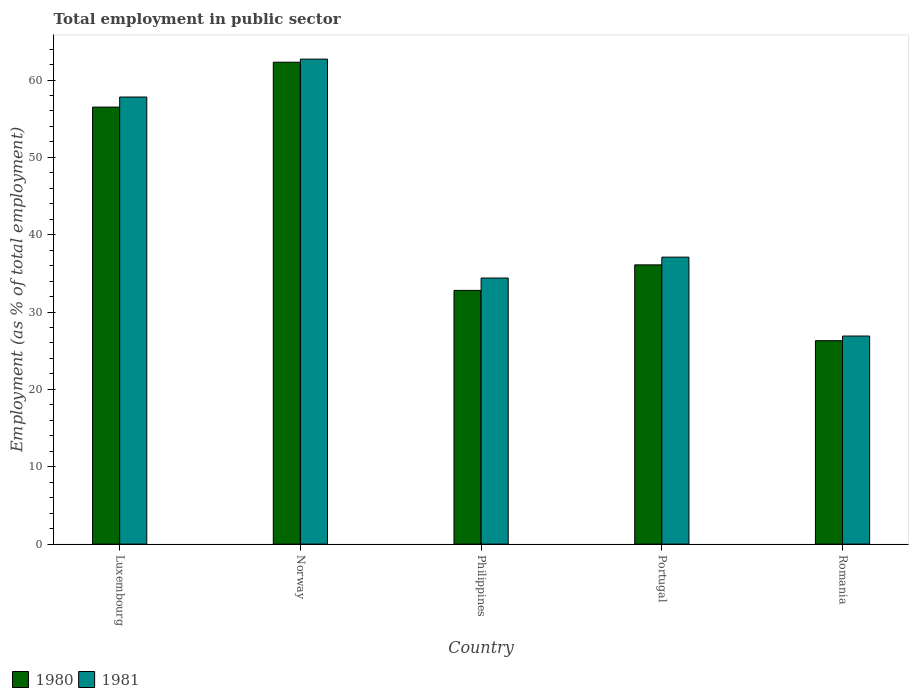What is the label of the 4th group of bars from the left?
Provide a succinct answer. Portugal. What is the employment in public sector in 1981 in Romania?
Your answer should be compact. 26.9. Across all countries, what is the maximum employment in public sector in 1980?
Your response must be concise. 62.3. Across all countries, what is the minimum employment in public sector in 1980?
Ensure brevity in your answer.  26.3. In which country was the employment in public sector in 1980 maximum?
Ensure brevity in your answer.  Norway. In which country was the employment in public sector in 1980 minimum?
Give a very brief answer. Romania. What is the total employment in public sector in 1981 in the graph?
Offer a very short reply. 218.9. What is the difference between the employment in public sector in 1981 in Philippines and that in Portugal?
Offer a very short reply. -2.7. What is the average employment in public sector in 1981 per country?
Your response must be concise. 43.78. What is the difference between the employment in public sector of/in 1980 and employment in public sector of/in 1981 in Portugal?
Your response must be concise. -1. What is the ratio of the employment in public sector in 1980 in Luxembourg to that in Norway?
Provide a succinct answer. 0.91. Is the difference between the employment in public sector in 1980 in Philippines and Portugal greater than the difference between the employment in public sector in 1981 in Philippines and Portugal?
Give a very brief answer. No. What is the difference between the highest and the second highest employment in public sector in 1980?
Make the answer very short. 20.4. Is the sum of the employment in public sector in 1980 in Philippines and Portugal greater than the maximum employment in public sector in 1981 across all countries?
Make the answer very short. Yes. How many bars are there?
Give a very brief answer. 10. Are all the bars in the graph horizontal?
Your response must be concise. No. Does the graph contain grids?
Offer a very short reply. No. Where does the legend appear in the graph?
Your answer should be compact. Bottom left. What is the title of the graph?
Provide a short and direct response. Total employment in public sector. Does "1960" appear as one of the legend labels in the graph?
Your response must be concise. No. What is the label or title of the X-axis?
Keep it short and to the point. Country. What is the label or title of the Y-axis?
Give a very brief answer. Employment (as % of total employment). What is the Employment (as % of total employment) of 1980 in Luxembourg?
Make the answer very short. 56.5. What is the Employment (as % of total employment) of 1981 in Luxembourg?
Provide a succinct answer. 57.8. What is the Employment (as % of total employment) of 1980 in Norway?
Keep it short and to the point. 62.3. What is the Employment (as % of total employment) in 1981 in Norway?
Ensure brevity in your answer.  62.7. What is the Employment (as % of total employment) in 1980 in Philippines?
Your answer should be very brief. 32.8. What is the Employment (as % of total employment) of 1981 in Philippines?
Give a very brief answer. 34.4. What is the Employment (as % of total employment) in 1980 in Portugal?
Your answer should be very brief. 36.1. What is the Employment (as % of total employment) of 1981 in Portugal?
Make the answer very short. 37.1. What is the Employment (as % of total employment) in 1980 in Romania?
Your answer should be compact. 26.3. What is the Employment (as % of total employment) of 1981 in Romania?
Provide a succinct answer. 26.9. Across all countries, what is the maximum Employment (as % of total employment) of 1980?
Ensure brevity in your answer.  62.3. Across all countries, what is the maximum Employment (as % of total employment) of 1981?
Provide a short and direct response. 62.7. Across all countries, what is the minimum Employment (as % of total employment) of 1980?
Keep it short and to the point. 26.3. Across all countries, what is the minimum Employment (as % of total employment) in 1981?
Ensure brevity in your answer.  26.9. What is the total Employment (as % of total employment) in 1980 in the graph?
Your answer should be compact. 214. What is the total Employment (as % of total employment) in 1981 in the graph?
Your answer should be compact. 218.9. What is the difference between the Employment (as % of total employment) in 1980 in Luxembourg and that in Philippines?
Provide a short and direct response. 23.7. What is the difference between the Employment (as % of total employment) of 1981 in Luxembourg and that in Philippines?
Offer a very short reply. 23.4. What is the difference between the Employment (as % of total employment) of 1980 in Luxembourg and that in Portugal?
Your answer should be compact. 20.4. What is the difference between the Employment (as % of total employment) in 1981 in Luxembourg and that in Portugal?
Your answer should be very brief. 20.7. What is the difference between the Employment (as % of total employment) in 1980 in Luxembourg and that in Romania?
Your response must be concise. 30.2. What is the difference between the Employment (as % of total employment) of 1981 in Luxembourg and that in Romania?
Your answer should be very brief. 30.9. What is the difference between the Employment (as % of total employment) in 1980 in Norway and that in Philippines?
Offer a very short reply. 29.5. What is the difference between the Employment (as % of total employment) of 1981 in Norway and that in Philippines?
Your answer should be very brief. 28.3. What is the difference between the Employment (as % of total employment) in 1980 in Norway and that in Portugal?
Your response must be concise. 26.2. What is the difference between the Employment (as % of total employment) in 1981 in Norway and that in Portugal?
Provide a short and direct response. 25.6. What is the difference between the Employment (as % of total employment) of 1980 in Norway and that in Romania?
Give a very brief answer. 36. What is the difference between the Employment (as % of total employment) in 1981 in Norway and that in Romania?
Offer a very short reply. 35.8. What is the difference between the Employment (as % of total employment) in 1981 in Philippines and that in Portugal?
Offer a terse response. -2.7. What is the difference between the Employment (as % of total employment) in 1981 in Portugal and that in Romania?
Provide a short and direct response. 10.2. What is the difference between the Employment (as % of total employment) of 1980 in Luxembourg and the Employment (as % of total employment) of 1981 in Norway?
Provide a short and direct response. -6.2. What is the difference between the Employment (as % of total employment) of 1980 in Luxembourg and the Employment (as % of total employment) of 1981 in Philippines?
Ensure brevity in your answer.  22.1. What is the difference between the Employment (as % of total employment) of 1980 in Luxembourg and the Employment (as % of total employment) of 1981 in Portugal?
Your answer should be very brief. 19.4. What is the difference between the Employment (as % of total employment) of 1980 in Luxembourg and the Employment (as % of total employment) of 1981 in Romania?
Offer a very short reply. 29.6. What is the difference between the Employment (as % of total employment) in 1980 in Norway and the Employment (as % of total employment) in 1981 in Philippines?
Your answer should be very brief. 27.9. What is the difference between the Employment (as % of total employment) of 1980 in Norway and the Employment (as % of total employment) of 1981 in Portugal?
Keep it short and to the point. 25.2. What is the difference between the Employment (as % of total employment) in 1980 in Norway and the Employment (as % of total employment) in 1981 in Romania?
Give a very brief answer. 35.4. What is the difference between the Employment (as % of total employment) in 1980 in Philippines and the Employment (as % of total employment) in 1981 in Romania?
Offer a very short reply. 5.9. What is the difference between the Employment (as % of total employment) in 1980 in Portugal and the Employment (as % of total employment) in 1981 in Romania?
Offer a very short reply. 9.2. What is the average Employment (as % of total employment) in 1980 per country?
Ensure brevity in your answer.  42.8. What is the average Employment (as % of total employment) in 1981 per country?
Your answer should be very brief. 43.78. What is the difference between the Employment (as % of total employment) in 1980 and Employment (as % of total employment) in 1981 in Philippines?
Your answer should be compact. -1.6. What is the difference between the Employment (as % of total employment) of 1980 and Employment (as % of total employment) of 1981 in Portugal?
Provide a succinct answer. -1. What is the difference between the Employment (as % of total employment) of 1980 and Employment (as % of total employment) of 1981 in Romania?
Your response must be concise. -0.6. What is the ratio of the Employment (as % of total employment) in 1980 in Luxembourg to that in Norway?
Offer a terse response. 0.91. What is the ratio of the Employment (as % of total employment) in 1981 in Luxembourg to that in Norway?
Your answer should be very brief. 0.92. What is the ratio of the Employment (as % of total employment) of 1980 in Luxembourg to that in Philippines?
Your response must be concise. 1.72. What is the ratio of the Employment (as % of total employment) in 1981 in Luxembourg to that in Philippines?
Offer a terse response. 1.68. What is the ratio of the Employment (as % of total employment) in 1980 in Luxembourg to that in Portugal?
Your response must be concise. 1.57. What is the ratio of the Employment (as % of total employment) of 1981 in Luxembourg to that in Portugal?
Offer a very short reply. 1.56. What is the ratio of the Employment (as % of total employment) in 1980 in Luxembourg to that in Romania?
Ensure brevity in your answer.  2.15. What is the ratio of the Employment (as % of total employment) of 1981 in Luxembourg to that in Romania?
Provide a short and direct response. 2.15. What is the ratio of the Employment (as % of total employment) of 1980 in Norway to that in Philippines?
Offer a very short reply. 1.9. What is the ratio of the Employment (as % of total employment) in 1981 in Norway to that in Philippines?
Offer a terse response. 1.82. What is the ratio of the Employment (as % of total employment) of 1980 in Norway to that in Portugal?
Offer a very short reply. 1.73. What is the ratio of the Employment (as % of total employment) of 1981 in Norway to that in Portugal?
Provide a succinct answer. 1.69. What is the ratio of the Employment (as % of total employment) of 1980 in Norway to that in Romania?
Provide a short and direct response. 2.37. What is the ratio of the Employment (as % of total employment) of 1981 in Norway to that in Romania?
Ensure brevity in your answer.  2.33. What is the ratio of the Employment (as % of total employment) of 1980 in Philippines to that in Portugal?
Provide a succinct answer. 0.91. What is the ratio of the Employment (as % of total employment) in 1981 in Philippines to that in Portugal?
Give a very brief answer. 0.93. What is the ratio of the Employment (as % of total employment) of 1980 in Philippines to that in Romania?
Make the answer very short. 1.25. What is the ratio of the Employment (as % of total employment) in 1981 in Philippines to that in Romania?
Ensure brevity in your answer.  1.28. What is the ratio of the Employment (as % of total employment) in 1980 in Portugal to that in Romania?
Your answer should be very brief. 1.37. What is the ratio of the Employment (as % of total employment) in 1981 in Portugal to that in Romania?
Make the answer very short. 1.38. What is the difference between the highest and the lowest Employment (as % of total employment) of 1980?
Offer a terse response. 36. What is the difference between the highest and the lowest Employment (as % of total employment) in 1981?
Offer a terse response. 35.8. 